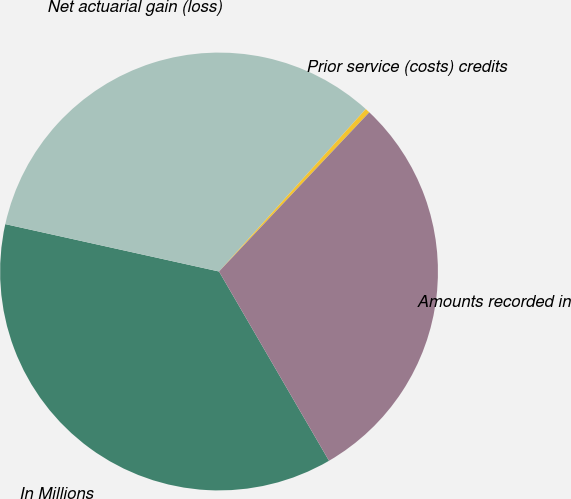Convert chart. <chart><loc_0><loc_0><loc_500><loc_500><pie_chart><fcel>In Millions<fcel>Net actuarial gain (loss)<fcel>Prior service (costs) credits<fcel>Amounts recorded in<nl><fcel>36.85%<fcel>33.22%<fcel>0.35%<fcel>29.58%<nl></chart> 